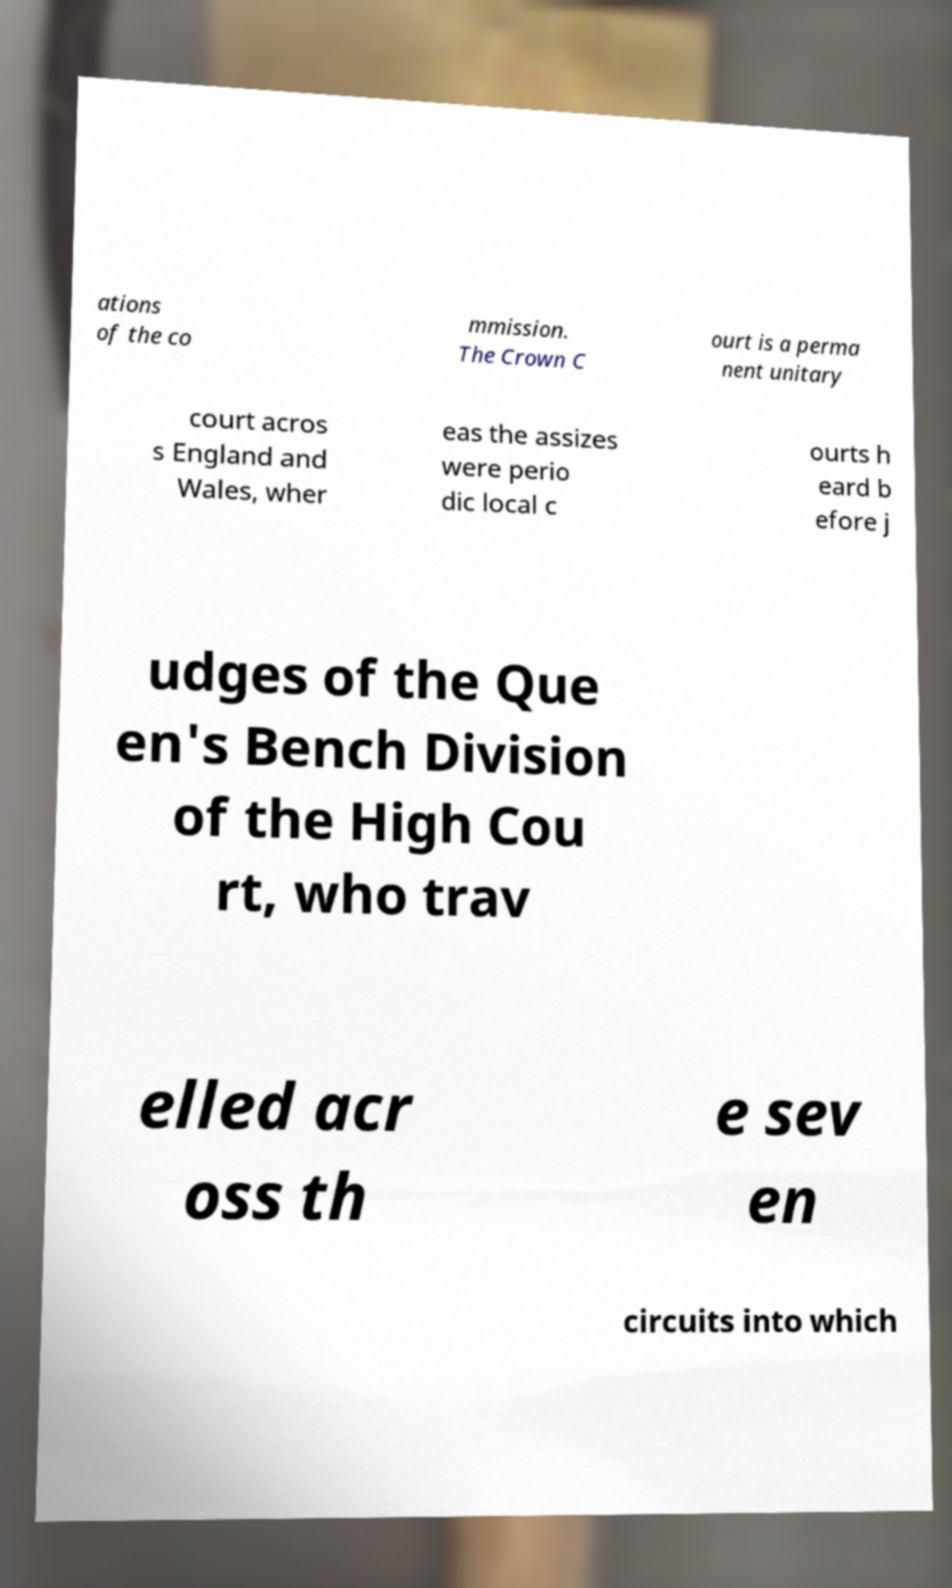I need the written content from this picture converted into text. Can you do that? ations of the co mmission. The Crown C ourt is a perma nent unitary court acros s England and Wales, wher eas the assizes were perio dic local c ourts h eard b efore j udges of the Que en's Bench Division of the High Cou rt, who trav elled acr oss th e sev en circuits into which 